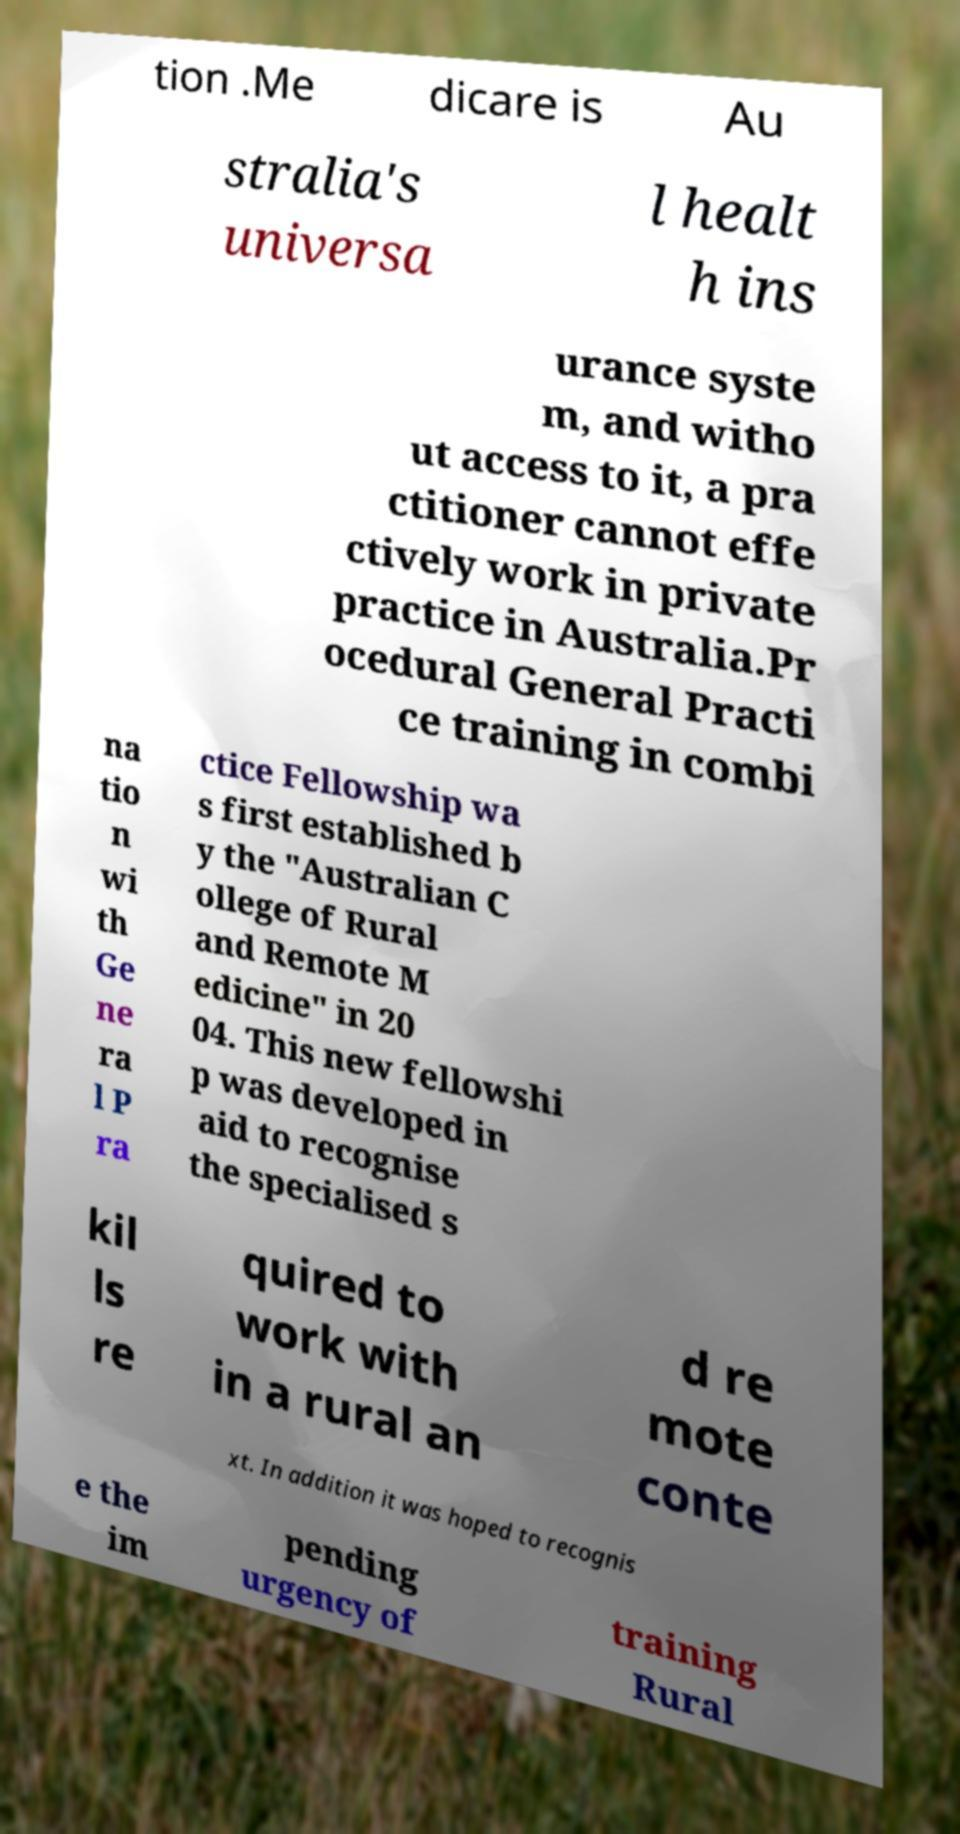Could you extract and type out the text from this image? tion .Me dicare is Au stralia's universa l healt h ins urance syste m, and witho ut access to it, a pra ctitioner cannot effe ctively work in private practice in Australia.Pr ocedural General Practi ce training in combi na tio n wi th Ge ne ra l P ra ctice Fellowship wa s first established b y the "Australian C ollege of Rural and Remote M edicine" in 20 04. This new fellowshi p was developed in aid to recognise the specialised s kil ls re quired to work with in a rural an d re mote conte xt. In addition it was hoped to recognis e the im pending urgency of training Rural 